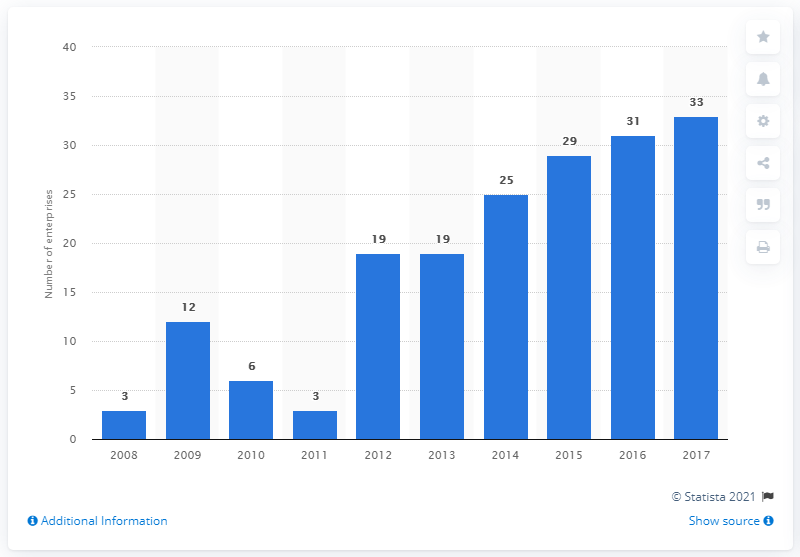Specify some key components in this picture. In 2017, there were 33 enterprises operating in the manufacture of cocoa, chocolate, and sugar confectionery industry. 